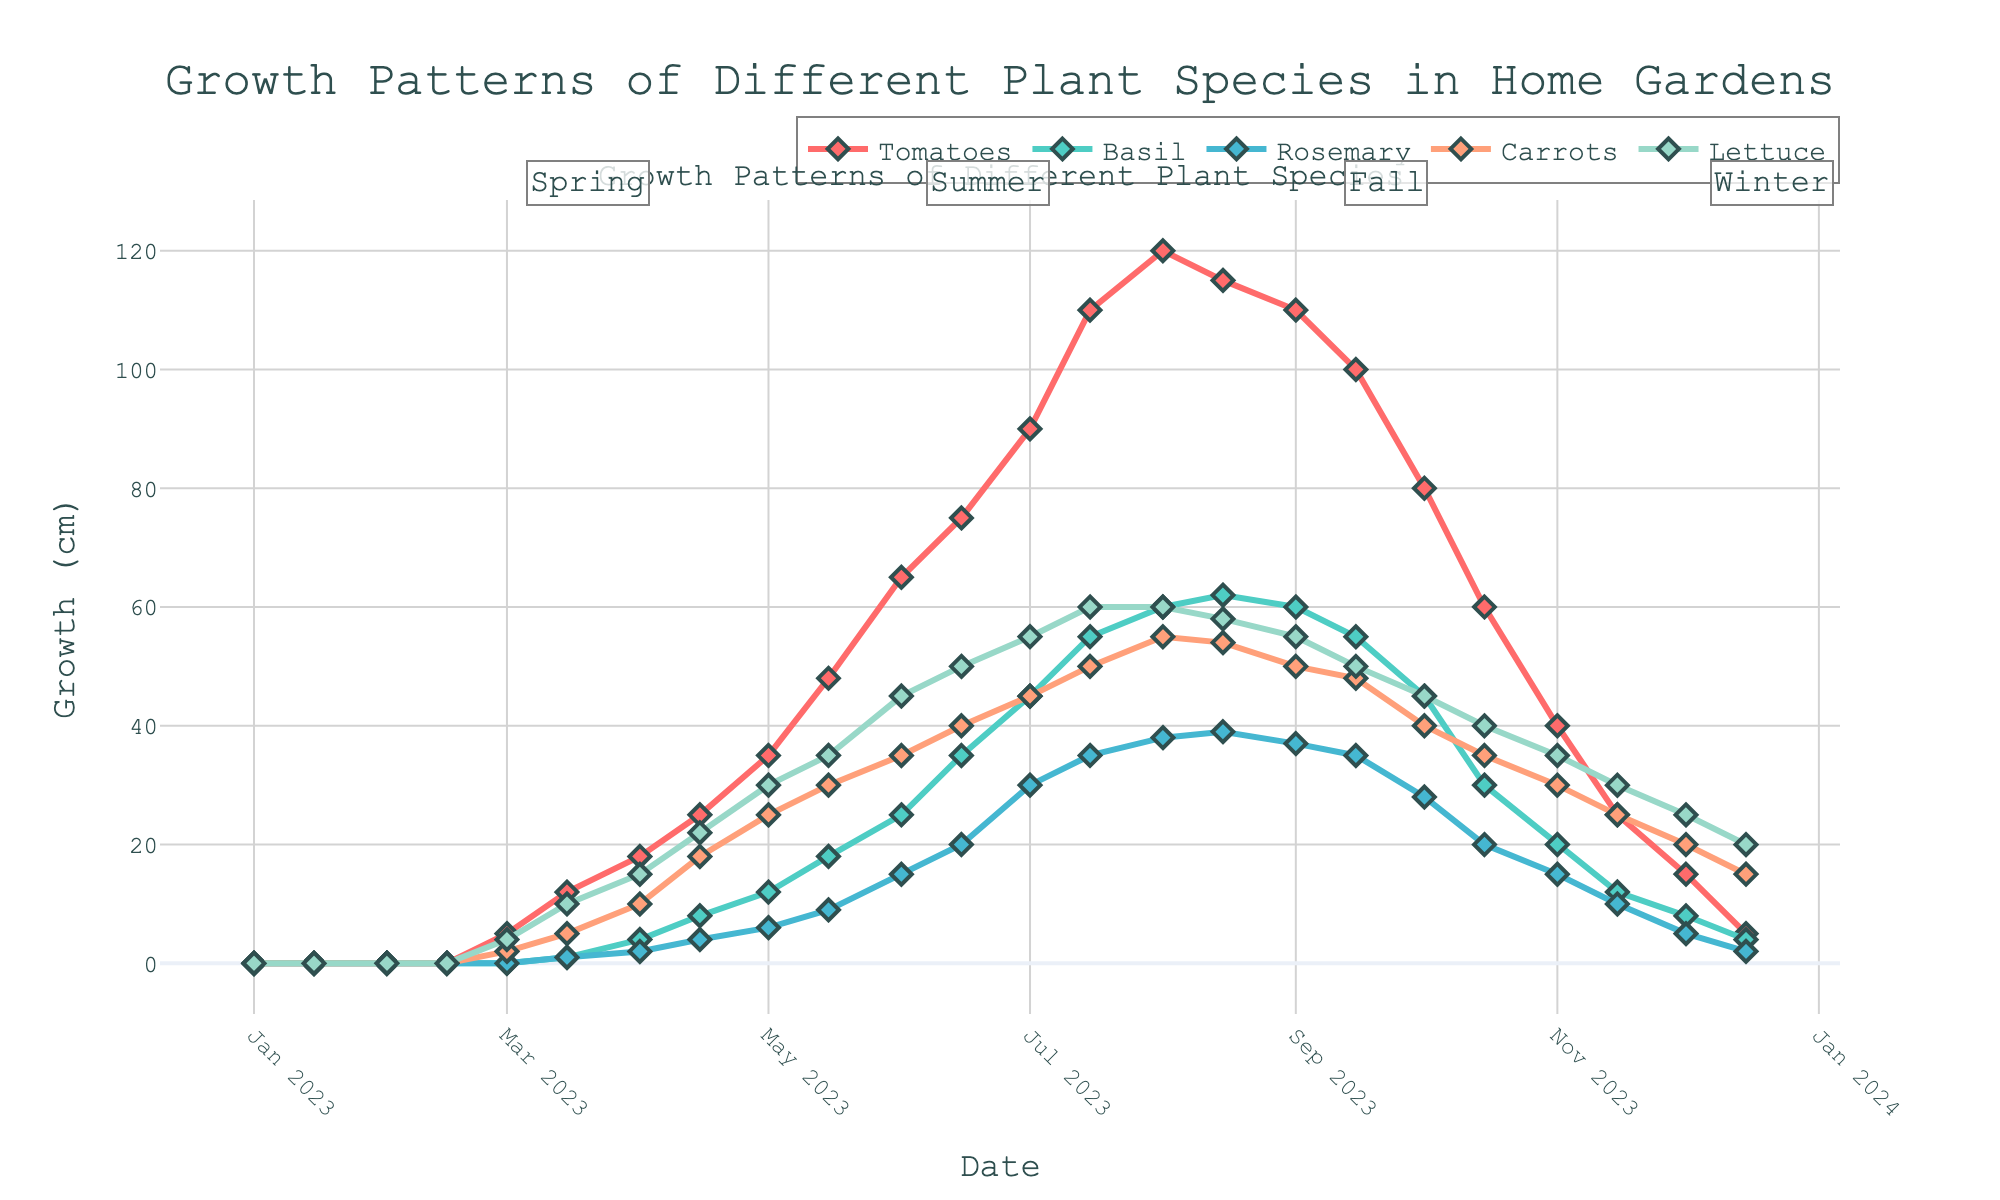What's the title of the figure? The title is located at the top of the figure, centered. It provides an overview of what the chart represents.
Answer: Growth Patterns of Different Plant Species in Home Gardens What does the x-axis represent? The x-axis is labeled below the horizontal line at the bottom of the figure. It indicates the timeline or date range during which the data was collected.
Answer: Date What color is used to represent Tomatoes in the figure? Each line representing a different plant species has a distinct color. By examining the key or legend, we can identify the specific color used for Tomatoes.
Answer: Red When did Carrots show the most growth? By looking at the Carrots' line and identifying its peak point, we can determine the date corresponding to the highest growth.
Answer: July 15, 2023 Which plant species had the highest growth in the summer season? Summer is annotated in the figure. By observing the growth patterns of all plant species during the summer months (June 21 to September 21), we can compare which one reached the highest point.
Answer: Tomatoes How did the growth of Lettuce change from October to December? We can track the Lettuce growth line from October through December and observe the differences in values.
Answer: It decreased Which two plant species had nearly identical growth in mid-April? By comparing the data points around mid-April, we can see which two lines are closest together in terms of growth.
Answer: Basil and Carrots What was the growth difference between Tomatoes and Basil on June 15? Locate the growth values for Tomatoes and Basil on June 15 and subtract the smaller value from the larger one.
Answer: 40 cm Which season shows the most consistent growth pattern for Rosemary? By observing the shape of the Rosemary line in different seasonal annotations, the seasonal section with the least fluctuation indicates the most consistent growth.
Answer: Summer What were the growth patterns of all plant species during the winter season? Winter is annotated in the figure. We need to observe the trends for all plant species during this period and summarize them.
Answer: All plant species showed a decline 